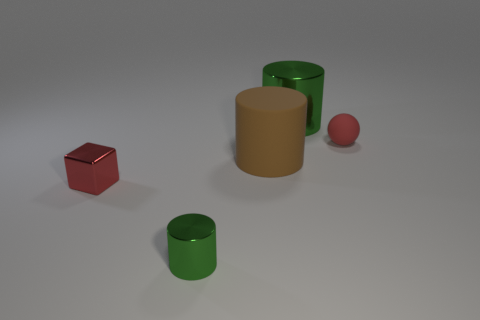Subtract all big brown cylinders. How many cylinders are left? 2 Subtract all gray balls. How many green cylinders are left? 2 Add 5 small red cubes. How many objects exist? 10 Subtract 1 cylinders. How many cylinders are left? 2 Subtract all cubes. How many objects are left? 4 Subtract all cyan cylinders. Subtract all purple blocks. How many cylinders are left? 3 Subtract all red rubber objects. Subtract all spheres. How many objects are left? 3 Add 3 brown things. How many brown things are left? 4 Add 3 tiny blue cylinders. How many tiny blue cylinders exist? 3 Subtract 0 green blocks. How many objects are left? 5 